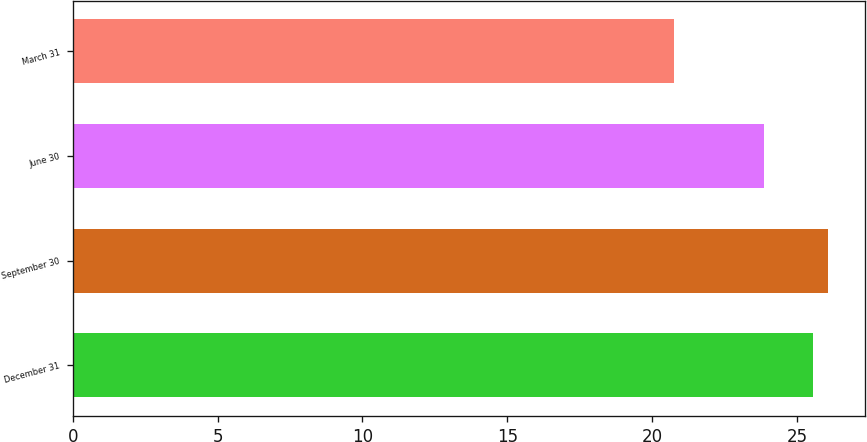Convert chart to OTSL. <chart><loc_0><loc_0><loc_500><loc_500><bar_chart><fcel>December 31<fcel>September 30<fcel>June 30<fcel>March 31<nl><fcel>25.56<fcel>26.06<fcel>23.88<fcel>20.75<nl></chart> 